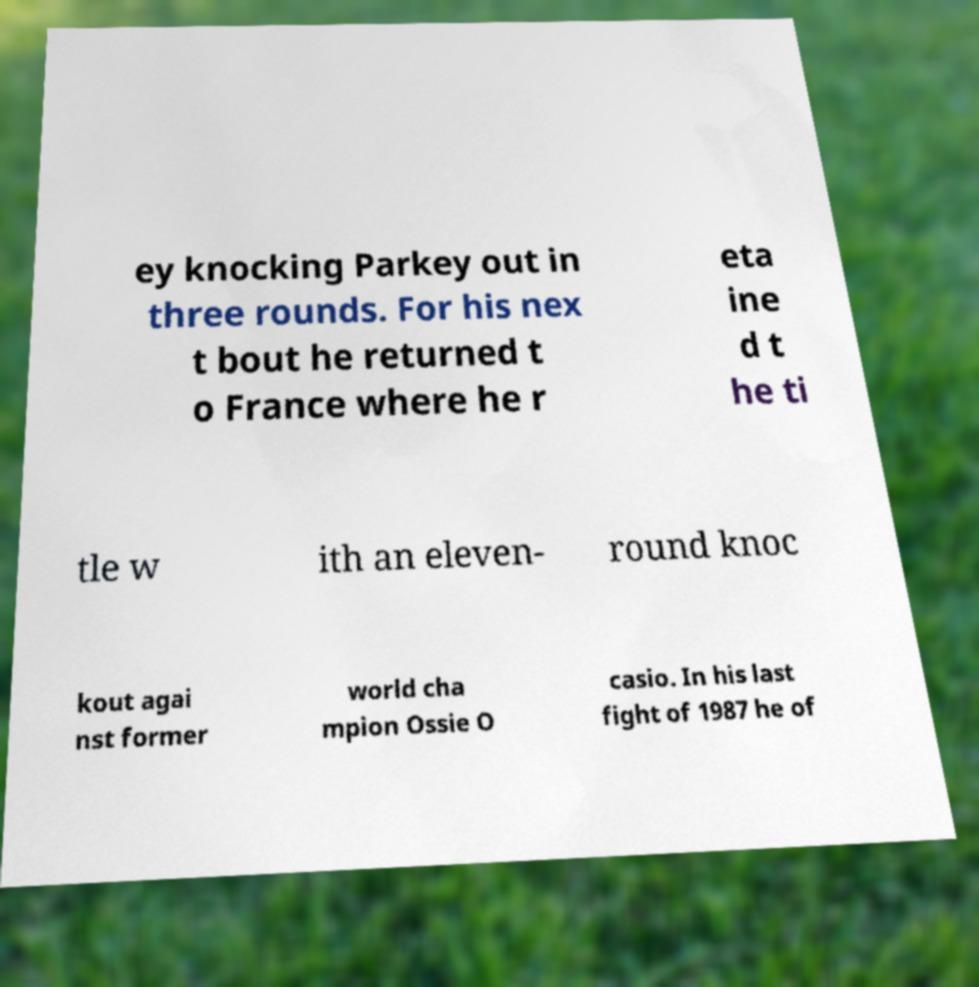Can you read and provide the text displayed in the image?This photo seems to have some interesting text. Can you extract and type it out for me? ey knocking Parkey out in three rounds. For his nex t bout he returned t o France where he r eta ine d t he ti tle w ith an eleven- round knoc kout agai nst former world cha mpion Ossie O casio. In his last fight of 1987 he of 